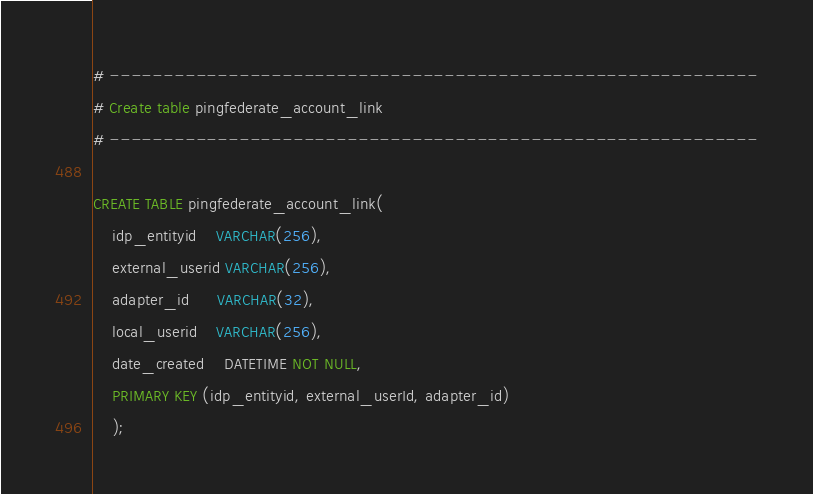Convert code to text. <code><loc_0><loc_0><loc_500><loc_500><_SQL_>
# ------------------------------------------------------------
# Create table pingfederate_account_link
# ------------------------------------------------------------

CREATE TABLE pingfederate_account_link(
    idp_entityid    VARCHAR(256),
    external_userid VARCHAR(256),
    adapter_id      VARCHAR(32),
    local_userid    VARCHAR(256),
    date_created    DATETIME NOT NULL,
    PRIMARY KEY (idp_entityid, external_userId, adapter_id)
    );
</code> 